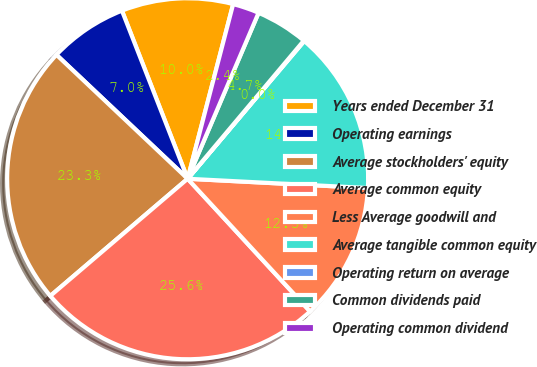<chart> <loc_0><loc_0><loc_500><loc_500><pie_chart><fcel>Years ended December 31<fcel>Operating earnings<fcel>Average stockholders' equity<fcel>Average common equity<fcel>Less Average goodwill and<fcel>Average tangible common equity<fcel>Operating return on average<fcel>Common dividends paid<fcel>Operating common dividend<nl><fcel>9.99%<fcel>7.02%<fcel>23.29%<fcel>25.62%<fcel>12.32%<fcel>14.64%<fcel>0.05%<fcel>4.7%<fcel>2.37%<nl></chart> 